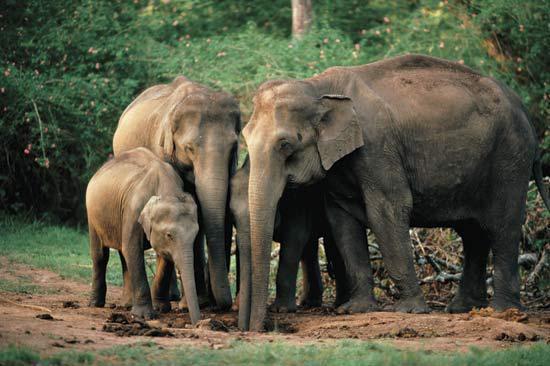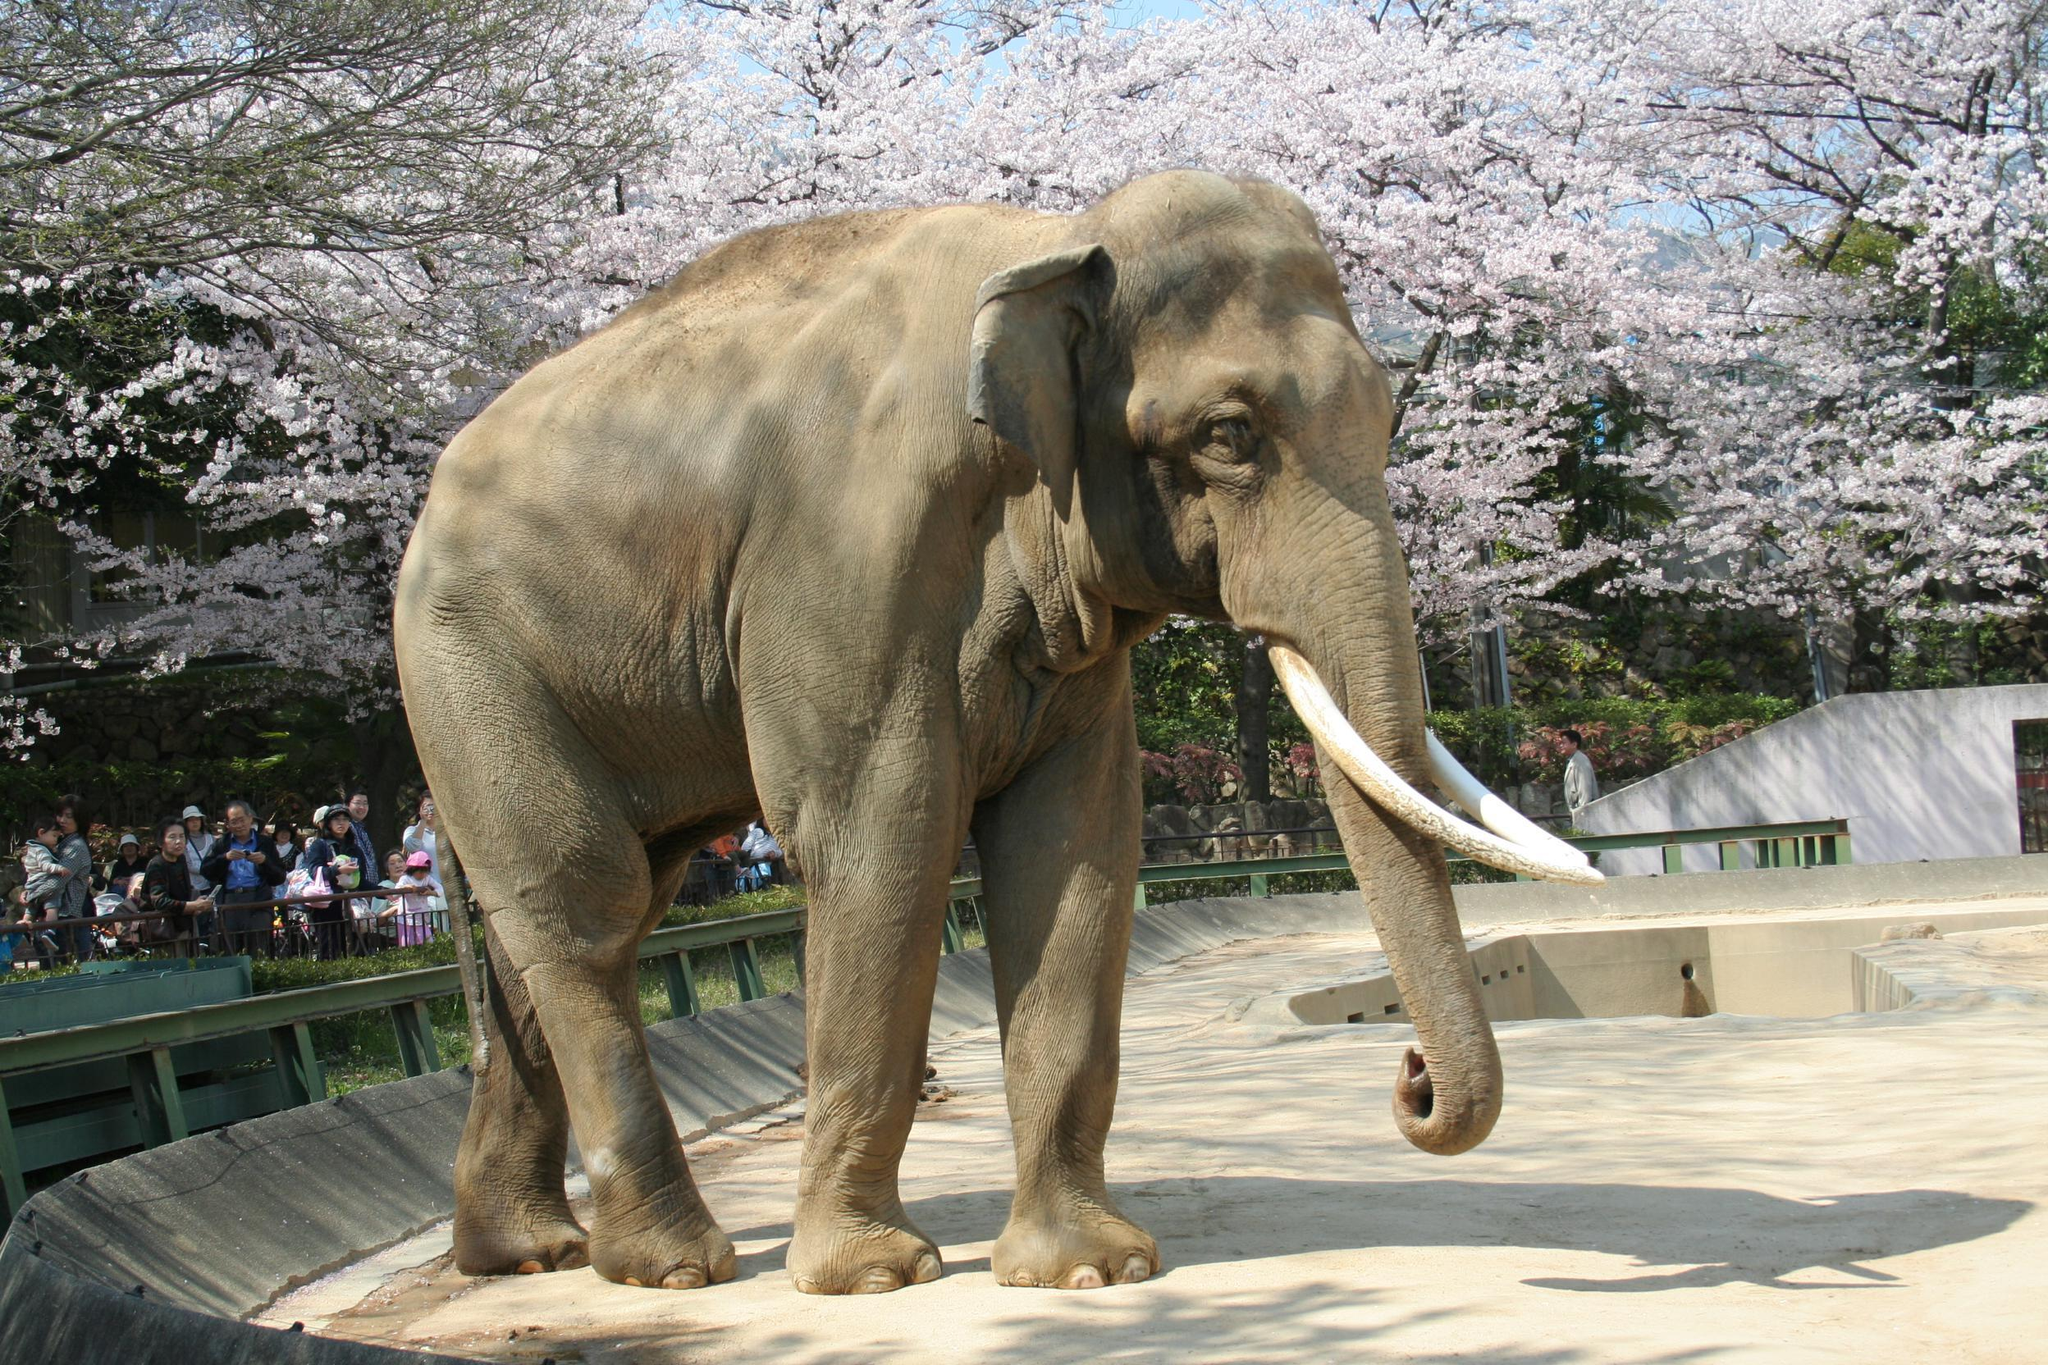The first image is the image on the left, the second image is the image on the right. For the images displayed, is the sentence "One of the images contains more than three elephants." factually correct? Answer yes or no. Yes. 